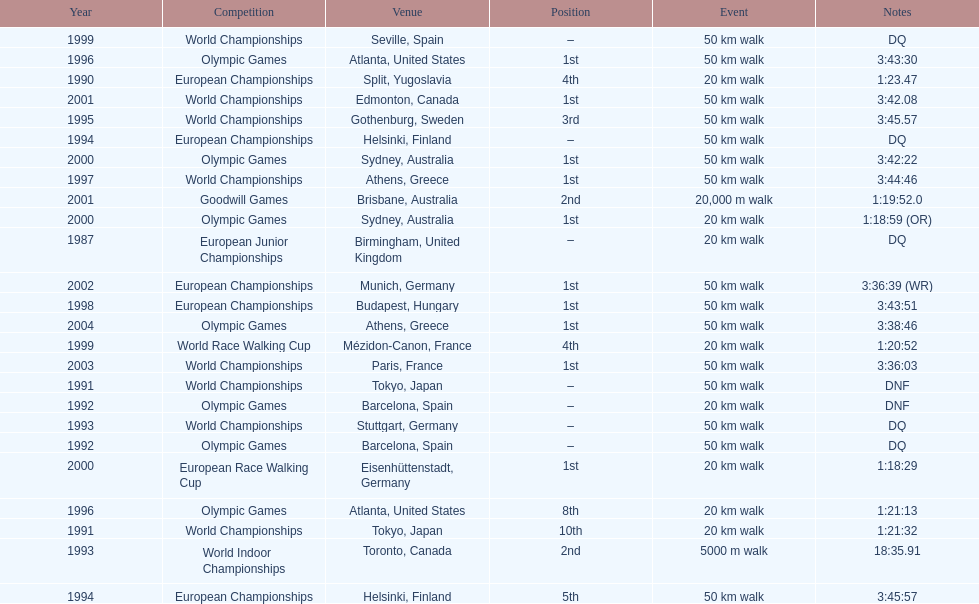How many times was first place listed as the position? 10. 